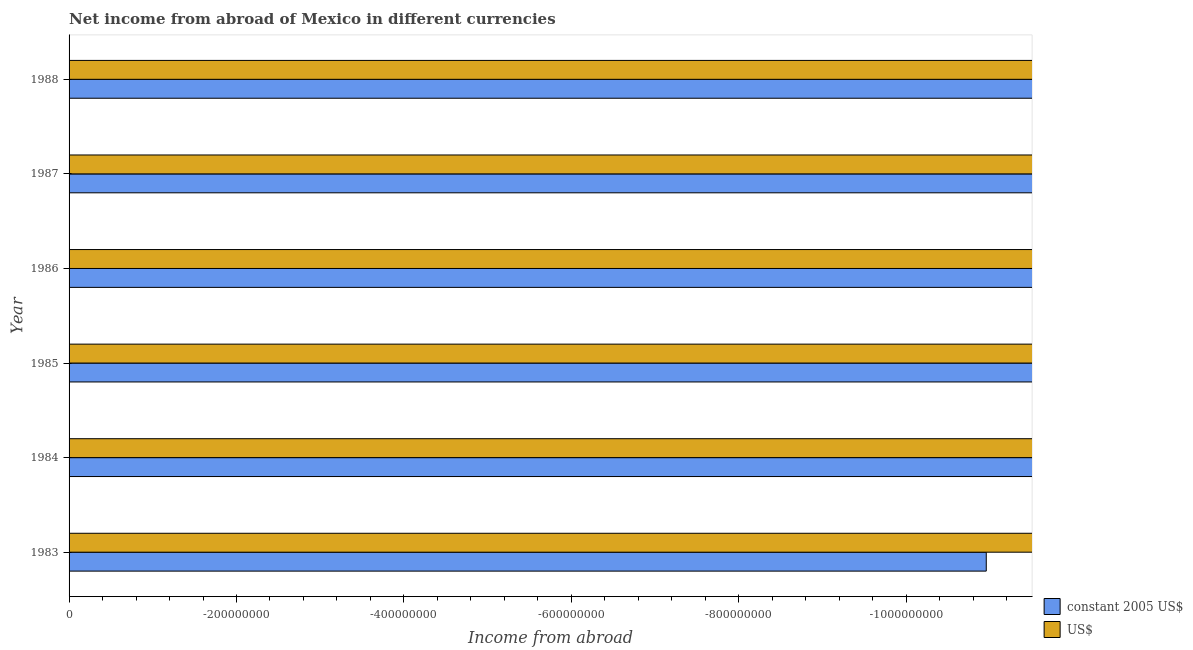How many different coloured bars are there?
Your answer should be compact. 0. Are the number of bars per tick equal to the number of legend labels?
Provide a succinct answer. No. Are the number of bars on each tick of the Y-axis equal?
Offer a terse response. Yes. How many bars are there on the 3rd tick from the top?
Your answer should be compact. 0. How many bars are there on the 6th tick from the bottom?
Make the answer very short. 0. In how many cases, is the number of bars for a given year not equal to the number of legend labels?
Your answer should be compact. 6. What is the total income from abroad in us$ in the graph?
Offer a terse response. 0. In how many years, is the income from abroad in us$ greater than -120000000 units?
Give a very brief answer. 0. In how many years, is the income from abroad in constant 2005 us$ greater than the average income from abroad in constant 2005 us$ taken over all years?
Provide a short and direct response. 0. Are all the bars in the graph horizontal?
Your answer should be compact. Yes. How many years are there in the graph?
Ensure brevity in your answer.  6. What is the difference between two consecutive major ticks on the X-axis?
Ensure brevity in your answer.  2.00e+08. Does the graph contain grids?
Offer a very short reply. No. How many legend labels are there?
Keep it short and to the point. 2. How are the legend labels stacked?
Your answer should be very brief. Vertical. What is the title of the graph?
Your answer should be very brief. Net income from abroad of Mexico in different currencies. What is the label or title of the X-axis?
Make the answer very short. Income from abroad. What is the Income from abroad of constant 2005 US$ in 1983?
Make the answer very short. 0. What is the Income from abroad of US$ in 1983?
Offer a terse response. 0. What is the Income from abroad of constant 2005 US$ in 1984?
Ensure brevity in your answer.  0. What is the Income from abroad in US$ in 1985?
Your answer should be very brief. 0. What is the Income from abroad in US$ in 1987?
Your response must be concise. 0. What is the Income from abroad in constant 2005 US$ in 1988?
Offer a terse response. 0. What is the total Income from abroad in constant 2005 US$ in the graph?
Offer a terse response. 0. What is the total Income from abroad in US$ in the graph?
Your answer should be very brief. 0. What is the average Income from abroad of constant 2005 US$ per year?
Provide a short and direct response. 0. 